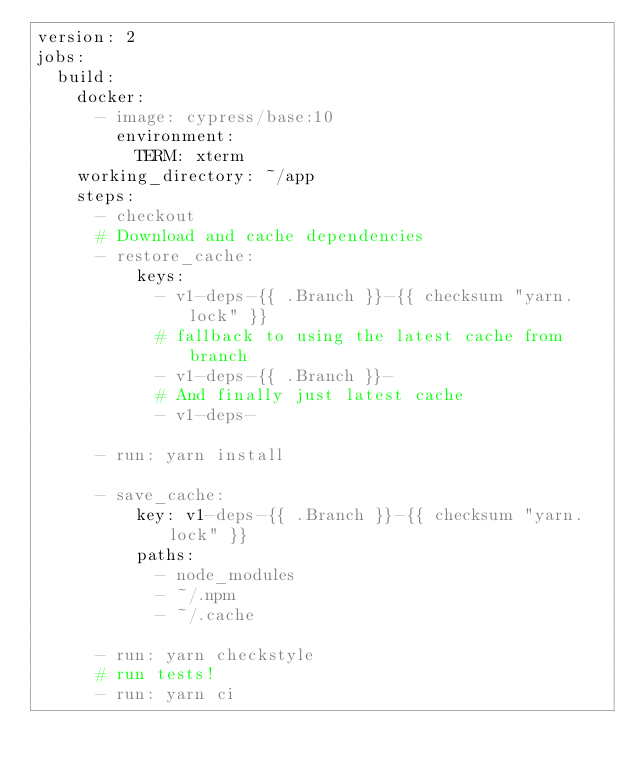<code> <loc_0><loc_0><loc_500><loc_500><_YAML_>version: 2
jobs:
  build:
    docker:
      - image: cypress/base:10
        environment:
          TERM: xterm
    working_directory: ~/app
    steps:
      - checkout
      # Download and cache dependencies
      - restore_cache:
          keys:
            - v1-deps-{{ .Branch }}-{{ checksum "yarn.lock" }}
            # fallback to using the latest cache from branch
            - v1-deps-{{ .Branch }}-
            # And finally just latest cache
            - v1-deps-

      - run: yarn install

      - save_cache:
          key: v1-deps-{{ .Branch }}-{{ checksum "yarn.lock" }}
          paths:
            - node_modules
            - ~/.npm
            - ~/.cache

      - run: yarn checkstyle
      # run tests!
      - run: yarn ci
</code> 